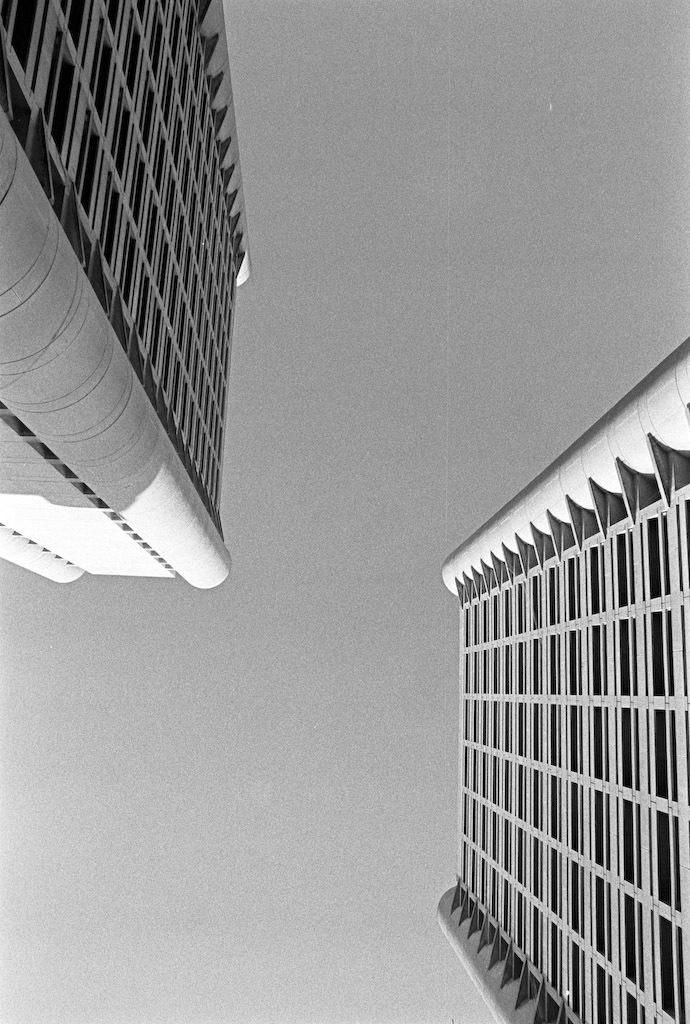What is the color scheme of the image? The image is black and white. What type of structures can be seen in the image? There are buildings in the image. What part of the natural environment is visible in the image? The sky is visible in the image. What is the tendency of the buildings to hate each other in the image? There is no indication of any emotions or relationships between the buildings in the image, so it is not possible to determine their tendency to hate each other. 